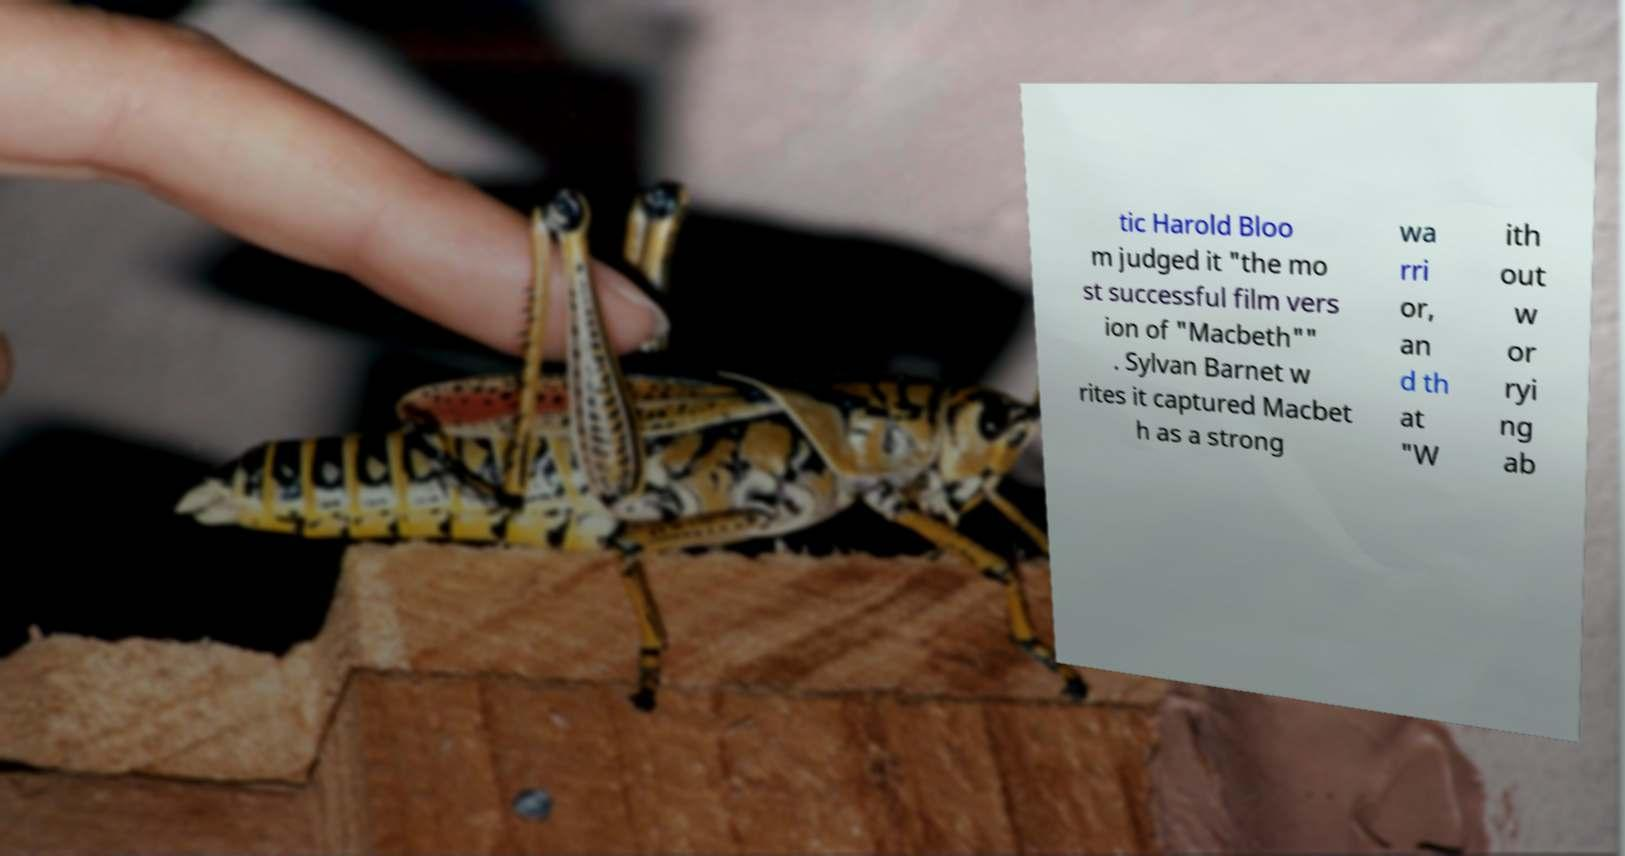Can you accurately transcribe the text from the provided image for me? tic Harold Bloo m judged it "the mo st successful film vers ion of "Macbeth"" . Sylvan Barnet w rites it captured Macbet h as a strong wa rri or, an d th at "W ith out w or ryi ng ab 